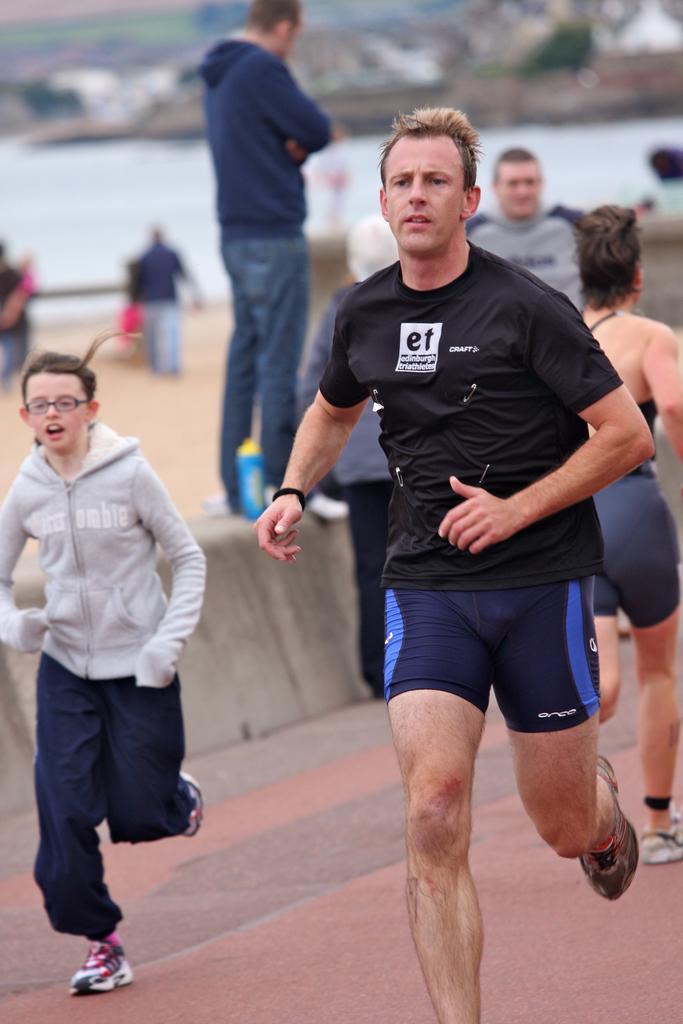Can you describe this image briefly? Background portion of the picture is blurry and we can see the people. In this picture we can see a man standing on the road divider and we can see a bottle. On the right side of the picture we can see the people running on the road. 